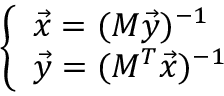Convert formula to latex. <formula><loc_0><loc_0><loc_500><loc_500>\left \{ \begin{array} { l l } { \vec { x } = ( M \vec { y } ) ^ { - 1 } } \\ { \vec { y } = ( M ^ { T } \vec { x } ) ^ { - 1 } } \end{array}</formula> 